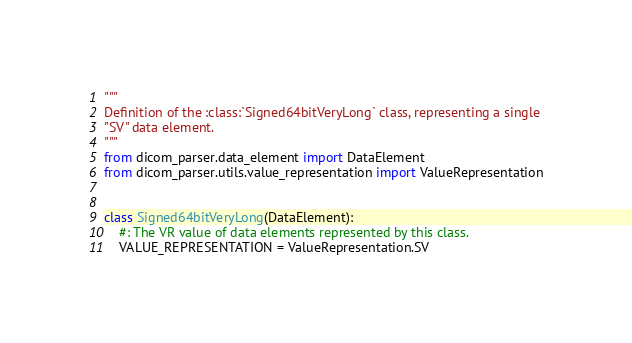Convert code to text. <code><loc_0><loc_0><loc_500><loc_500><_Python_>"""
Definition of the :class:`Signed64bitVeryLong` class, representing a single
"SV" data element.
"""
from dicom_parser.data_element import DataElement
from dicom_parser.utils.value_representation import ValueRepresentation


class Signed64bitVeryLong(DataElement):
    #: The VR value of data elements represented by this class.
    VALUE_REPRESENTATION = ValueRepresentation.SV
</code> 